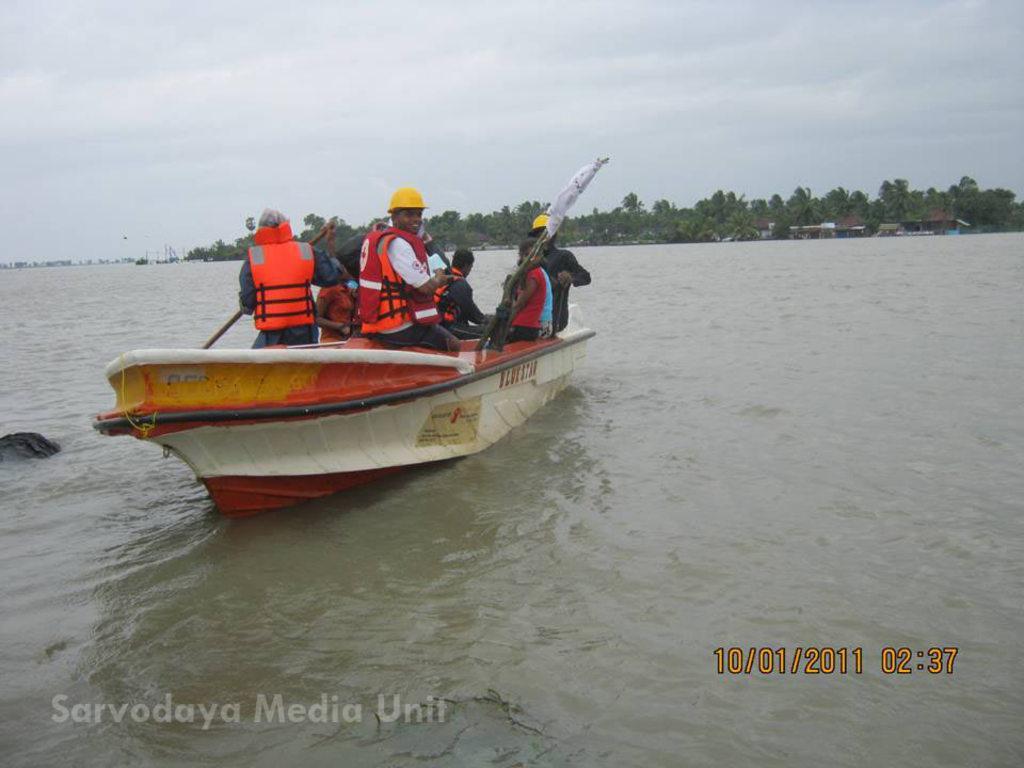Could you give a brief overview of what you see in this image? In this image we can see a boat on the surface of water. There are some people in the boat. There are some trees and houses in the background of the image. At the top of the image, we can see the sky with clouds. We can see watermarks at the bottom of the image. 